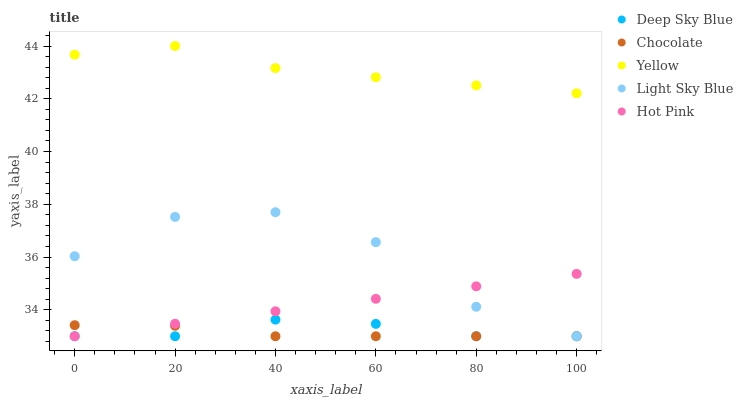Does Chocolate have the minimum area under the curve?
Answer yes or no. Yes. Does Yellow have the maximum area under the curve?
Answer yes or no. Yes. Does Light Sky Blue have the minimum area under the curve?
Answer yes or no. No. Does Light Sky Blue have the maximum area under the curve?
Answer yes or no. No. Is Hot Pink the smoothest?
Answer yes or no. Yes. Is Light Sky Blue the roughest?
Answer yes or no. Yes. Is Yellow the smoothest?
Answer yes or no. No. Is Yellow the roughest?
Answer yes or no. No. Does Hot Pink have the lowest value?
Answer yes or no. Yes. Does Yellow have the lowest value?
Answer yes or no. No. Does Yellow have the highest value?
Answer yes or no. Yes. Does Light Sky Blue have the highest value?
Answer yes or no. No. Is Chocolate less than Yellow?
Answer yes or no. Yes. Is Yellow greater than Chocolate?
Answer yes or no. Yes. Does Chocolate intersect Deep Sky Blue?
Answer yes or no. Yes. Is Chocolate less than Deep Sky Blue?
Answer yes or no. No. Is Chocolate greater than Deep Sky Blue?
Answer yes or no. No. Does Chocolate intersect Yellow?
Answer yes or no. No. 